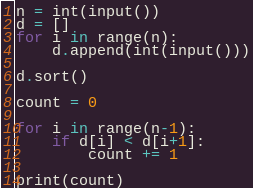<code> <loc_0><loc_0><loc_500><loc_500><_Python_>n = int(input())
d = []
for i in range(n):
    d.append(int(input()))

d.sort()

count = 0

for i in range(n-1):
    if d[i] < d[i+1]:
        count += 1

print(count)</code> 